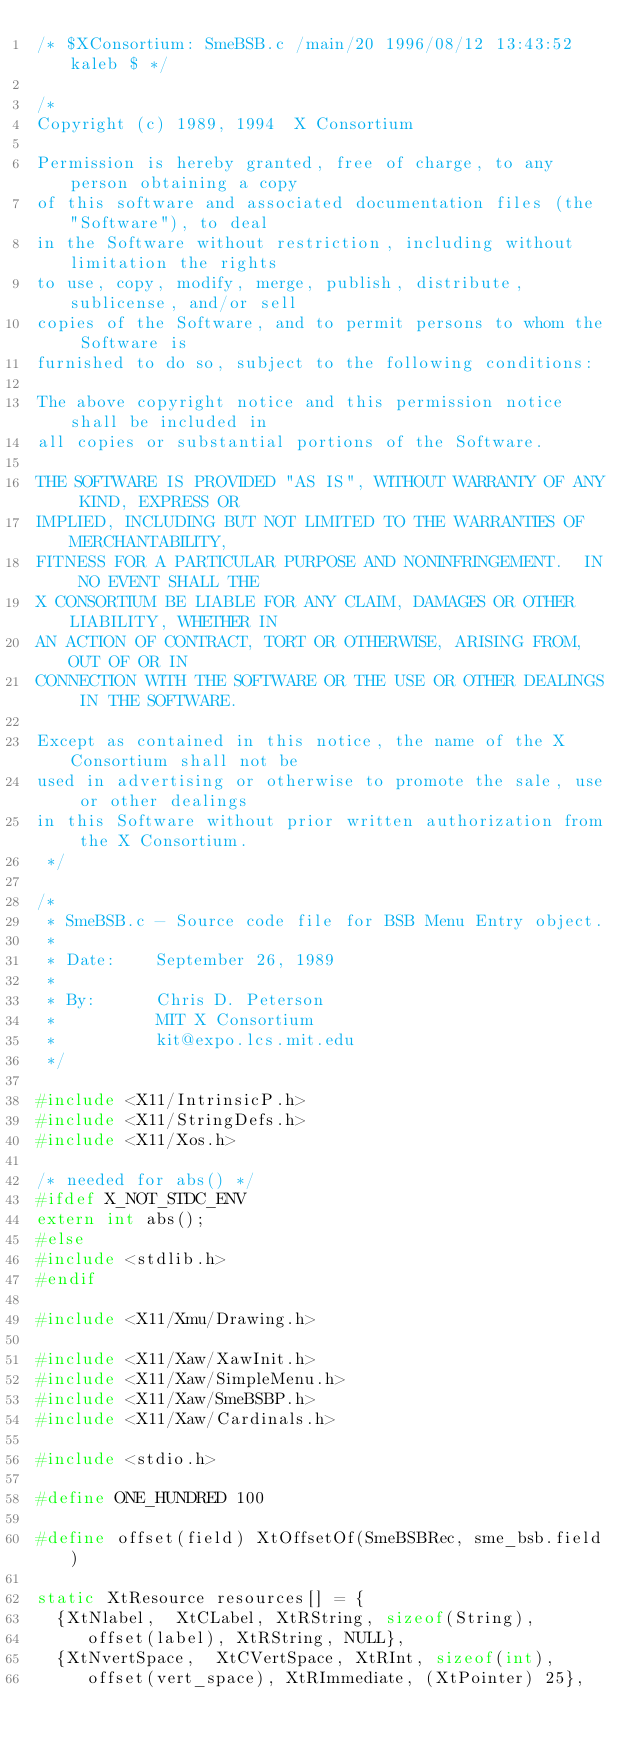Convert code to text. <code><loc_0><loc_0><loc_500><loc_500><_C_>/* $XConsortium: SmeBSB.c /main/20 1996/08/12 13:43:52 kaleb $ */

/*
Copyright (c) 1989, 1994  X Consortium

Permission is hereby granted, free of charge, to any person obtaining a copy
of this software and associated documentation files (the "Software"), to deal
in the Software without restriction, including without limitation the rights
to use, copy, modify, merge, publish, distribute, sublicense, and/or sell
copies of the Software, and to permit persons to whom the Software is
furnished to do so, subject to the following conditions:

The above copyright notice and this permission notice shall be included in
all copies or substantial portions of the Software.

THE SOFTWARE IS PROVIDED "AS IS", WITHOUT WARRANTY OF ANY KIND, EXPRESS OR
IMPLIED, INCLUDING BUT NOT LIMITED TO THE WARRANTIES OF MERCHANTABILITY,
FITNESS FOR A PARTICULAR PURPOSE AND NONINFRINGEMENT.  IN NO EVENT SHALL THE
X CONSORTIUM BE LIABLE FOR ANY CLAIM, DAMAGES OR OTHER LIABILITY, WHETHER IN
AN ACTION OF CONTRACT, TORT OR OTHERWISE, ARISING FROM, OUT OF OR IN
CONNECTION WITH THE SOFTWARE OR THE USE OR OTHER DEALINGS IN THE SOFTWARE.

Except as contained in this notice, the name of the X Consortium shall not be
used in advertising or otherwise to promote the sale, use or other dealings
in this Software without prior written authorization from the X Consortium.
 */

/*
 * SmeBSB.c - Source code file for BSB Menu Entry object.
 *
 * Date:    September 26, 1989
 *
 * By:      Chris D. Peterson
 *          MIT X Consortium 
 *          kit@expo.lcs.mit.edu
 */

#include <X11/IntrinsicP.h>
#include <X11/StringDefs.h>
#include <X11/Xos.h>

/* needed for abs() */
#ifdef X_NOT_STDC_ENV
extern int abs();
#else
#include <stdlib.h>
#endif

#include <X11/Xmu/Drawing.h>

#include <X11/Xaw/XawInit.h>
#include <X11/Xaw/SimpleMenu.h>
#include <X11/Xaw/SmeBSBP.h>
#include <X11/Xaw/Cardinals.h>

#include <stdio.h>

#define ONE_HUNDRED 100

#define offset(field) XtOffsetOf(SmeBSBRec, sme_bsb.field)

static XtResource resources[] = {
  {XtNlabel,  XtCLabel, XtRString, sizeof(String),
     offset(label), XtRString, NULL},
  {XtNvertSpace,  XtCVertSpace, XtRInt, sizeof(int),
     offset(vert_space), XtRImmediate, (XtPointer) 25},</code> 